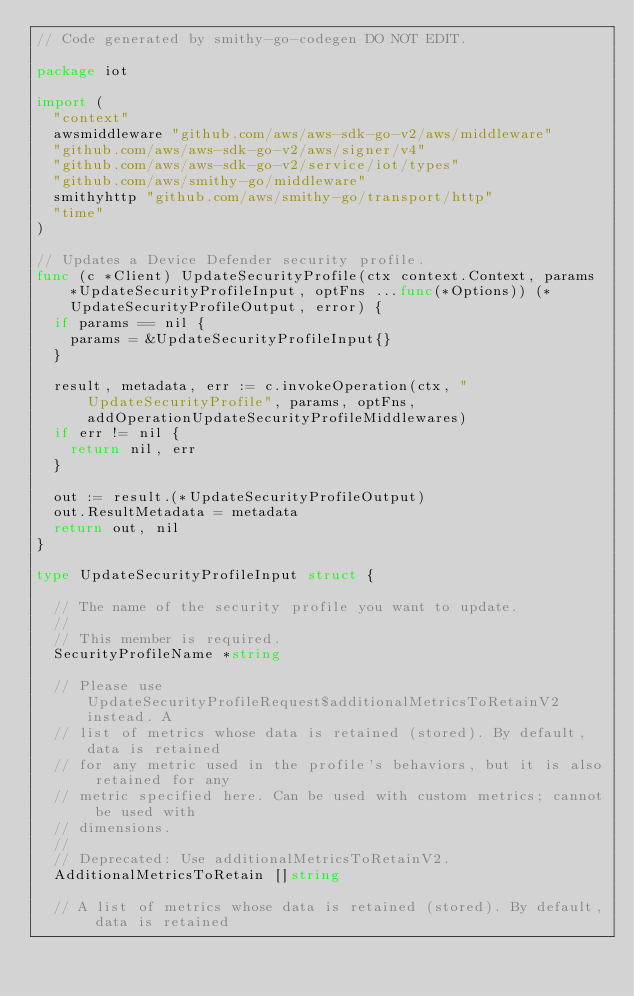Convert code to text. <code><loc_0><loc_0><loc_500><loc_500><_Go_>// Code generated by smithy-go-codegen DO NOT EDIT.

package iot

import (
	"context"
	awsmiddleware "github.com/aws/aws-sdk-go-v2/aws/middleware"
	"github.com/aws/aws-sdk-go-v2/aws/signer/v4"
	"github.com/aws/aws-sdk-go-v2/service/iot/types"
	"github.com/aws/smithy-go/middleware"
	smithyhttp "github.com/aws/smithy-go/transport/http"
	"time"
)

// Updates a Device Defender security profile.
func (c *Client) UpdateSecurityProfile(ctx context.Context, params *UpdateSecurityProfileInput, optFns ...func(*Options)) (*UpdateSecurityProfileOutput, error) {
	if params == nil {
		params = &UpdateSecurityProfileInput{}
	}

	result, metadata, err := c.invokeOperation(ctx, "UpdateSecurityProfile", params, optFns, addOperationUpdateSecurityProfileMiddlewares)
	if err != nil {
		return nil, err
	}

	out := result.(*UpdateSecurityProfileOutput)
	out.ResultMetadata = metadata
	return out, nil
}

type UpdateSecurityProfileInput struct {

	// The name of the security profile you want to update.
	//
	// This member is required.
	SecurityProfileName *string

	// Please use UpdateSecurityProfileRequest$additionalMetricsToRetainV2 instead. A
	// list of metrics whose data is retained (stored). By default, data is retained
	// for any metric used in the profile's behaviors, but it is also retained for any
	// metric specified here. Can be used with custom metrics; cannot be used with
	// dimensions.
	//
	// Deprecated: Use additionalMetricsToRetainV2.
	AdditionalMetricsToRetain []string

	// A list of metrics whose data is retained (stored). By default, data is retained</code> 